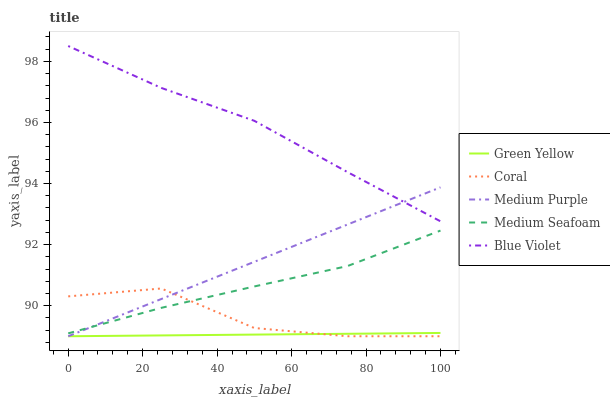Does Green Yellow have the minimum area under the curve?
Answer yes or no. Yes. Does Blue Violet have the maximum area under the curve?
Answer yes or no. Yes. Does Coral have the minimum area under the curve?
Answer yes or no. No. Does Coral have the maximum area under the curve?
Answer yes or no. No. Is Green Yellow the smoothest?
Answer yes or no. Yes. Is Coral the roughest?
Answer yes or no. Yes. Is Coral the smoothest?
Answer yes or no. No. Is Green Yellow the roughest?
Answer yes or no. No. Does Medium Purple have the lowest value?
Answer yes or no. Yes. Does Medium Seafoam have the lowest value?
Answer yes or no. No. Does Blue Violet have the highest value?
Answer yes or no. Yes. Does Coral have the highest value?
Answer yes or no. No. Is Coral less than Blue Violet?
Answer yes or no. Yes. Is Blue Violet greater than Green Yellow?
Answer yes or no. Yes. Does Medium Purple intersect Blue Violet?
Answer yes or no. Yes. Is Medium Purple less than Blue Violet?
Answer yes or no. No. Is Medium Purple greater than Blue Violet?
Answer yes or no. No. Does Coral intersect Blue Violet?
Answer yes or no. No. 